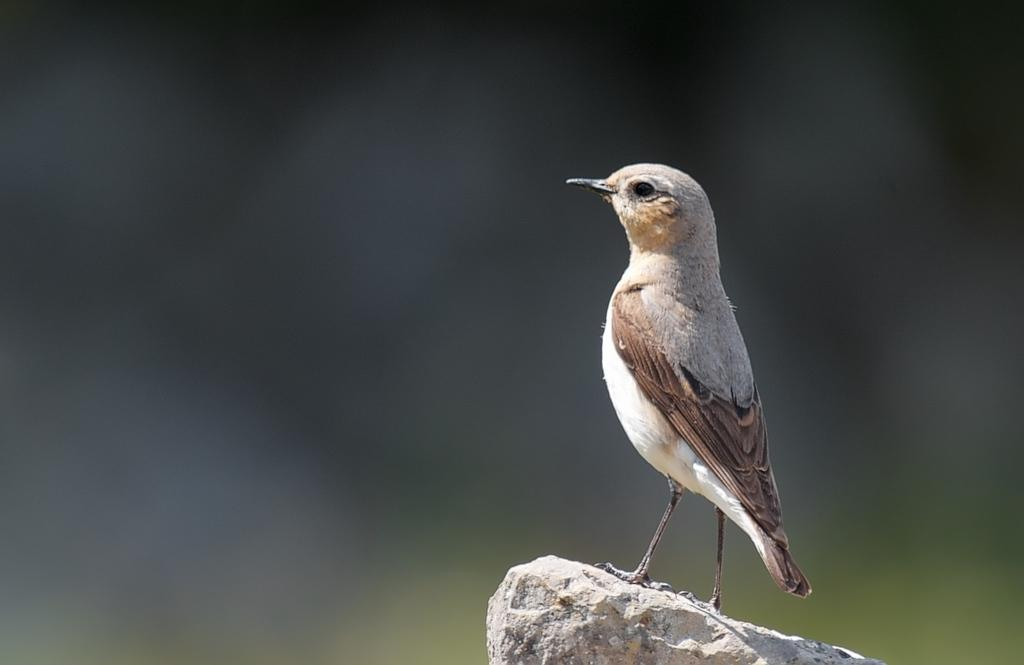What type of animal is in the image? There is a bird in the image. Where is the bird located? The bird is on a rock. Can you describe the background of the image? The background of the image is blurred. What letter is the bird holding in its grip in the image? There is no letter present in the image, and the bird is not holding anything. 